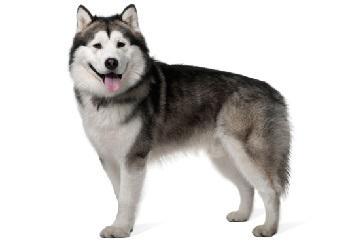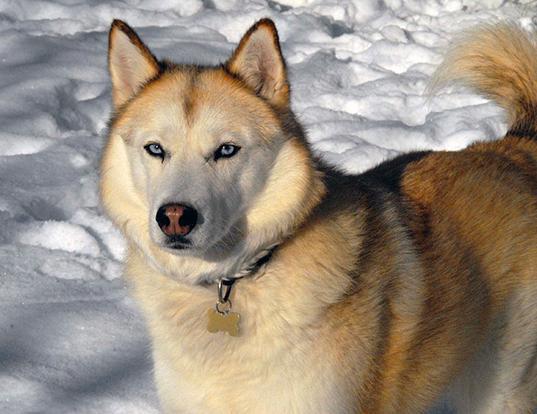The first image is the image on the left, the second image is the image on the right. Assess this claim about the two images: "All dogs are in snowy scenes, and the left image features a reclining black-and-white husky, while the right image features an upright husky.". Correct or not? Answer yes or no. No. The first image is the image on the left, the second image is the image on the right. Evaluate the accuracy of this statement regarding the images: "in at least one image the is a brown and white husky outside in the snow standing.". Is it true? Answer yes or no. Yes. 